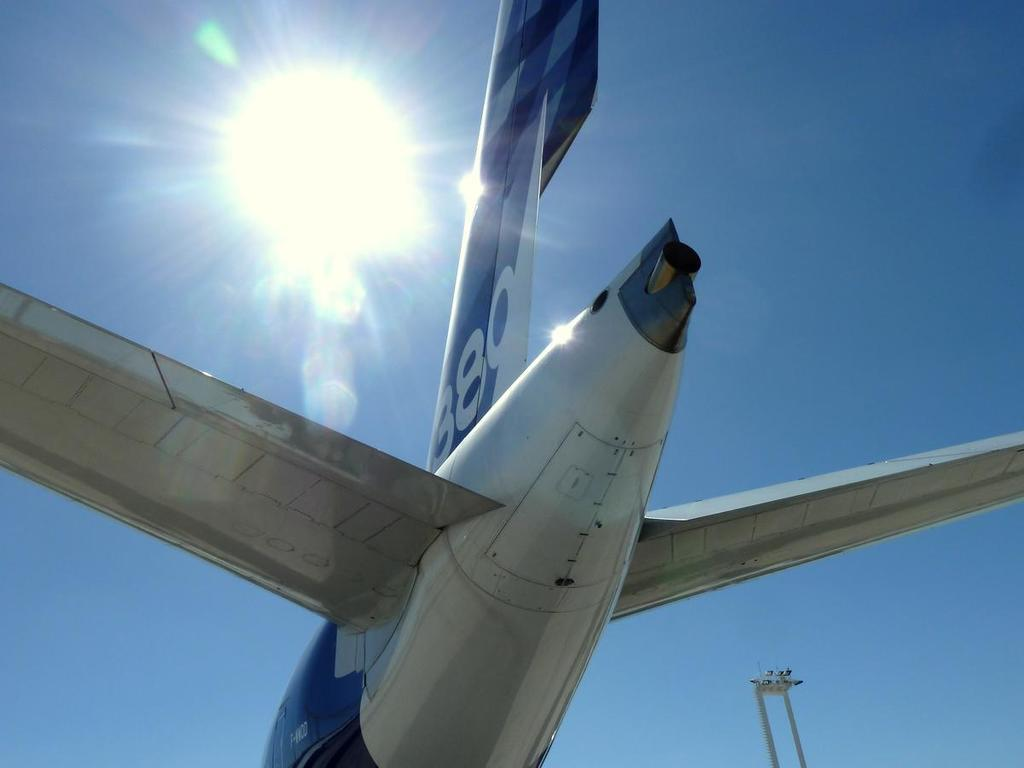<image>
Summarize the visual content of the image. A blue and white jet tail with the number 889. 